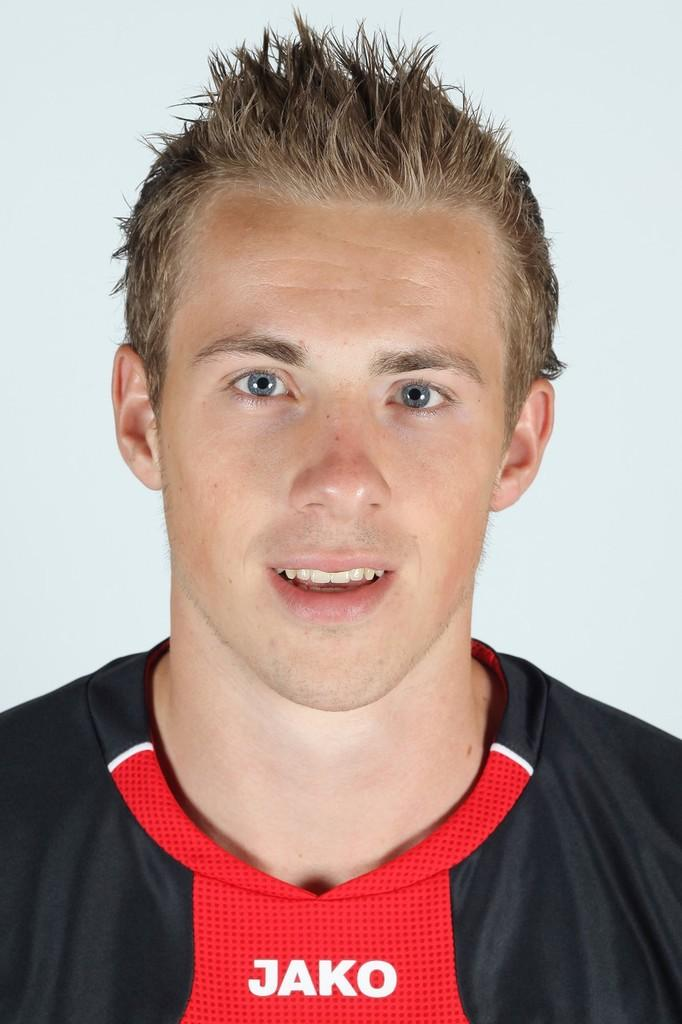<image>
Share a concise interpretation of the image provided. A young blond male in a red and black jako jersey. 